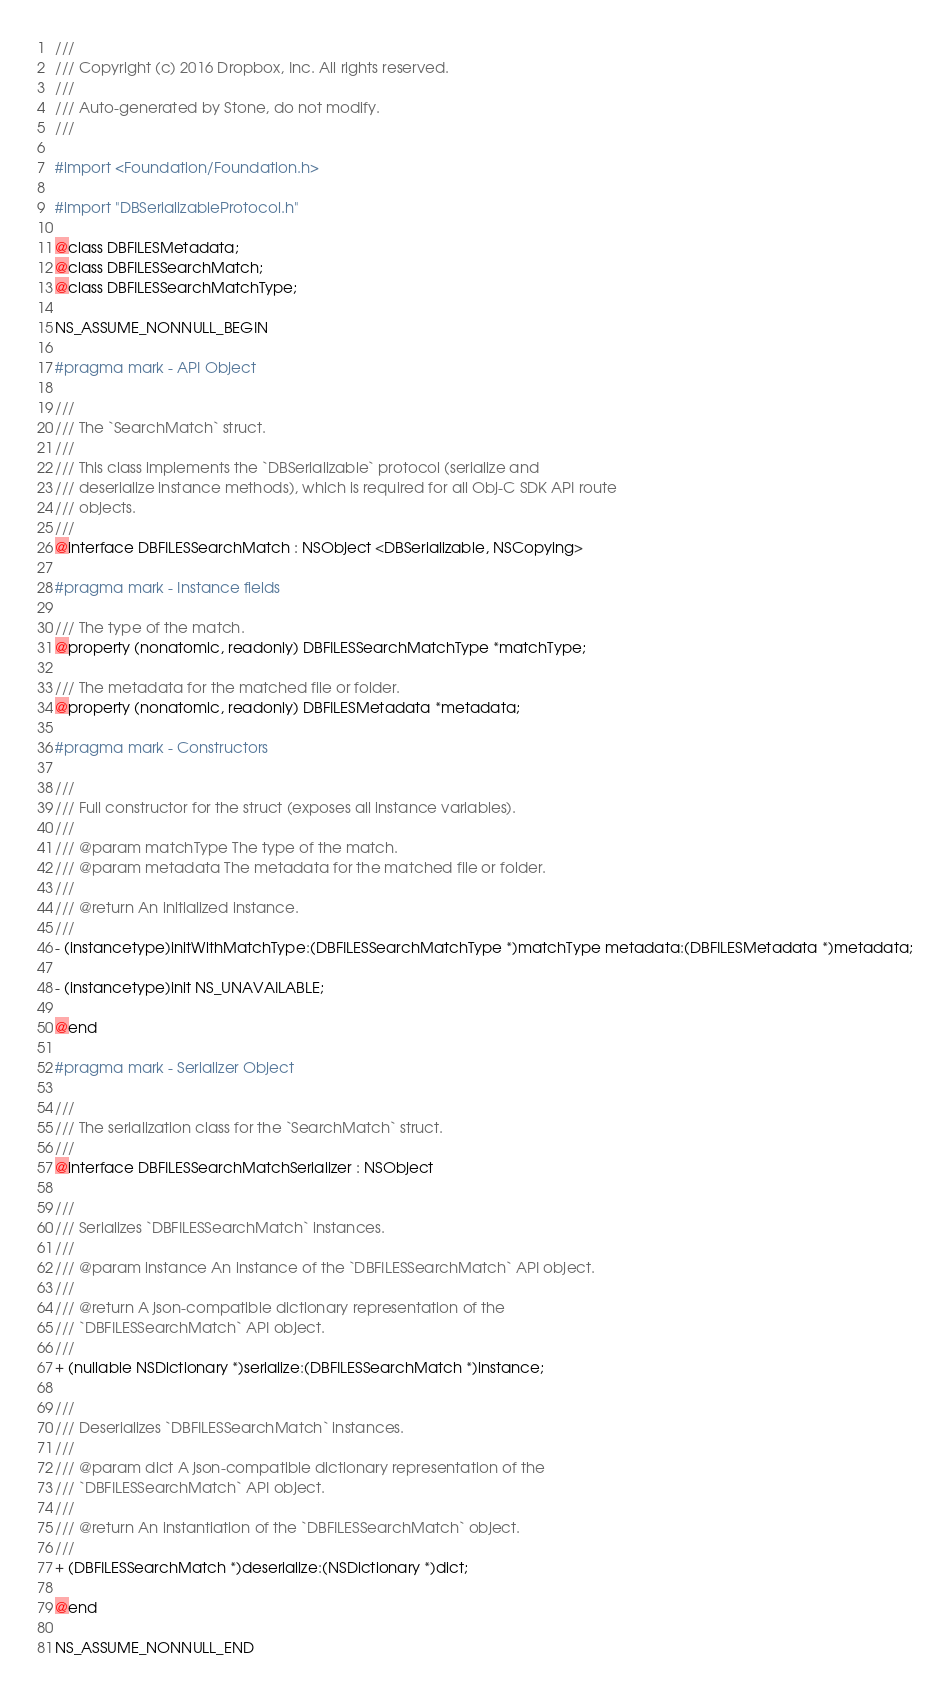<code> <loc_0><loc_0><loc_500><loc_500><_C_>///
/// Copyright (c) 2016 Dropbox, Inc. All rights reserved.
///
/// Auto-generated by Stone, do not modify.
///

#import <Foundation/Foundation.h>

#import "DBSerializableProtocol.h"

@class DBFILESMetadata;
@class DBFILESSearchMatch;
@class DBFILESSearchMatchType;

NS_ASSUME_NONNULL_BEGIN

#pragma mark - API Object

///
/// The `SearchMatch` struct.
///
/// This class implements the `DBSerializable` protocol (serialize and
/// deserialize instance methods), which is required for all Obj-C SDK API route
/// objects.
///
@interface DBFILESSearchMatch : NSObject <DBSerializable, NSCopying>

#pragma mark - Instance fields

/// The type of the match.
@property (nonatomic, readonly) DBFILESSearchMatchType *matchType;

/// The metadata for the matched file or folder.
@property (nonatomic, readonly) DBFILESMetadata *metadata;

#pragma mark - Constructors

///
/// Full constructor for the struct (exposes all instance variables).
///
/// @param matchType The type of the match.
/// @param metadata The metadata for the matched file or folder.
///
/// @return An initialized instance.
///
- (instancetype)initWithMatchType:(DBFILESSearchMatchType *)matchType metadata:(DBFILESMetadata *)metadata;

- (instancetype)init NS_UNAVAILABLE;

@end

#pragma mark - Serializer Object

///
/// The serialization class for the `SearchMatch` struct.
///
@interface DBFILESSearchMatchSerializer : NSObject

///
/// Serializes `DBFILESSearchMatch` instances.
///
/// @param instance An instance of the `DBFILESSearchMatch` API object.
///
/// @return A json-compatible dictionary representation of the
/// `DBFILESSearchMatch` API object.
///
+ (nullable NSDictionary *)serialize:(DBFILESSearchMatch *)instance;

///
/// Deserializes `DBFILESSearchMatch` instances.
///
/// @param dict A json-compatible dictionary representation of the
/// `DBFILESSearchMatch` API object.
///
/// @return An instantiation of the `DBFILESSearchMatch` object.
///
+ (DBFILESSearchMatch *)deserialize:(NSDictionary *)dict;

@end

NS_ASSUME_NONNULL_END
</code> 